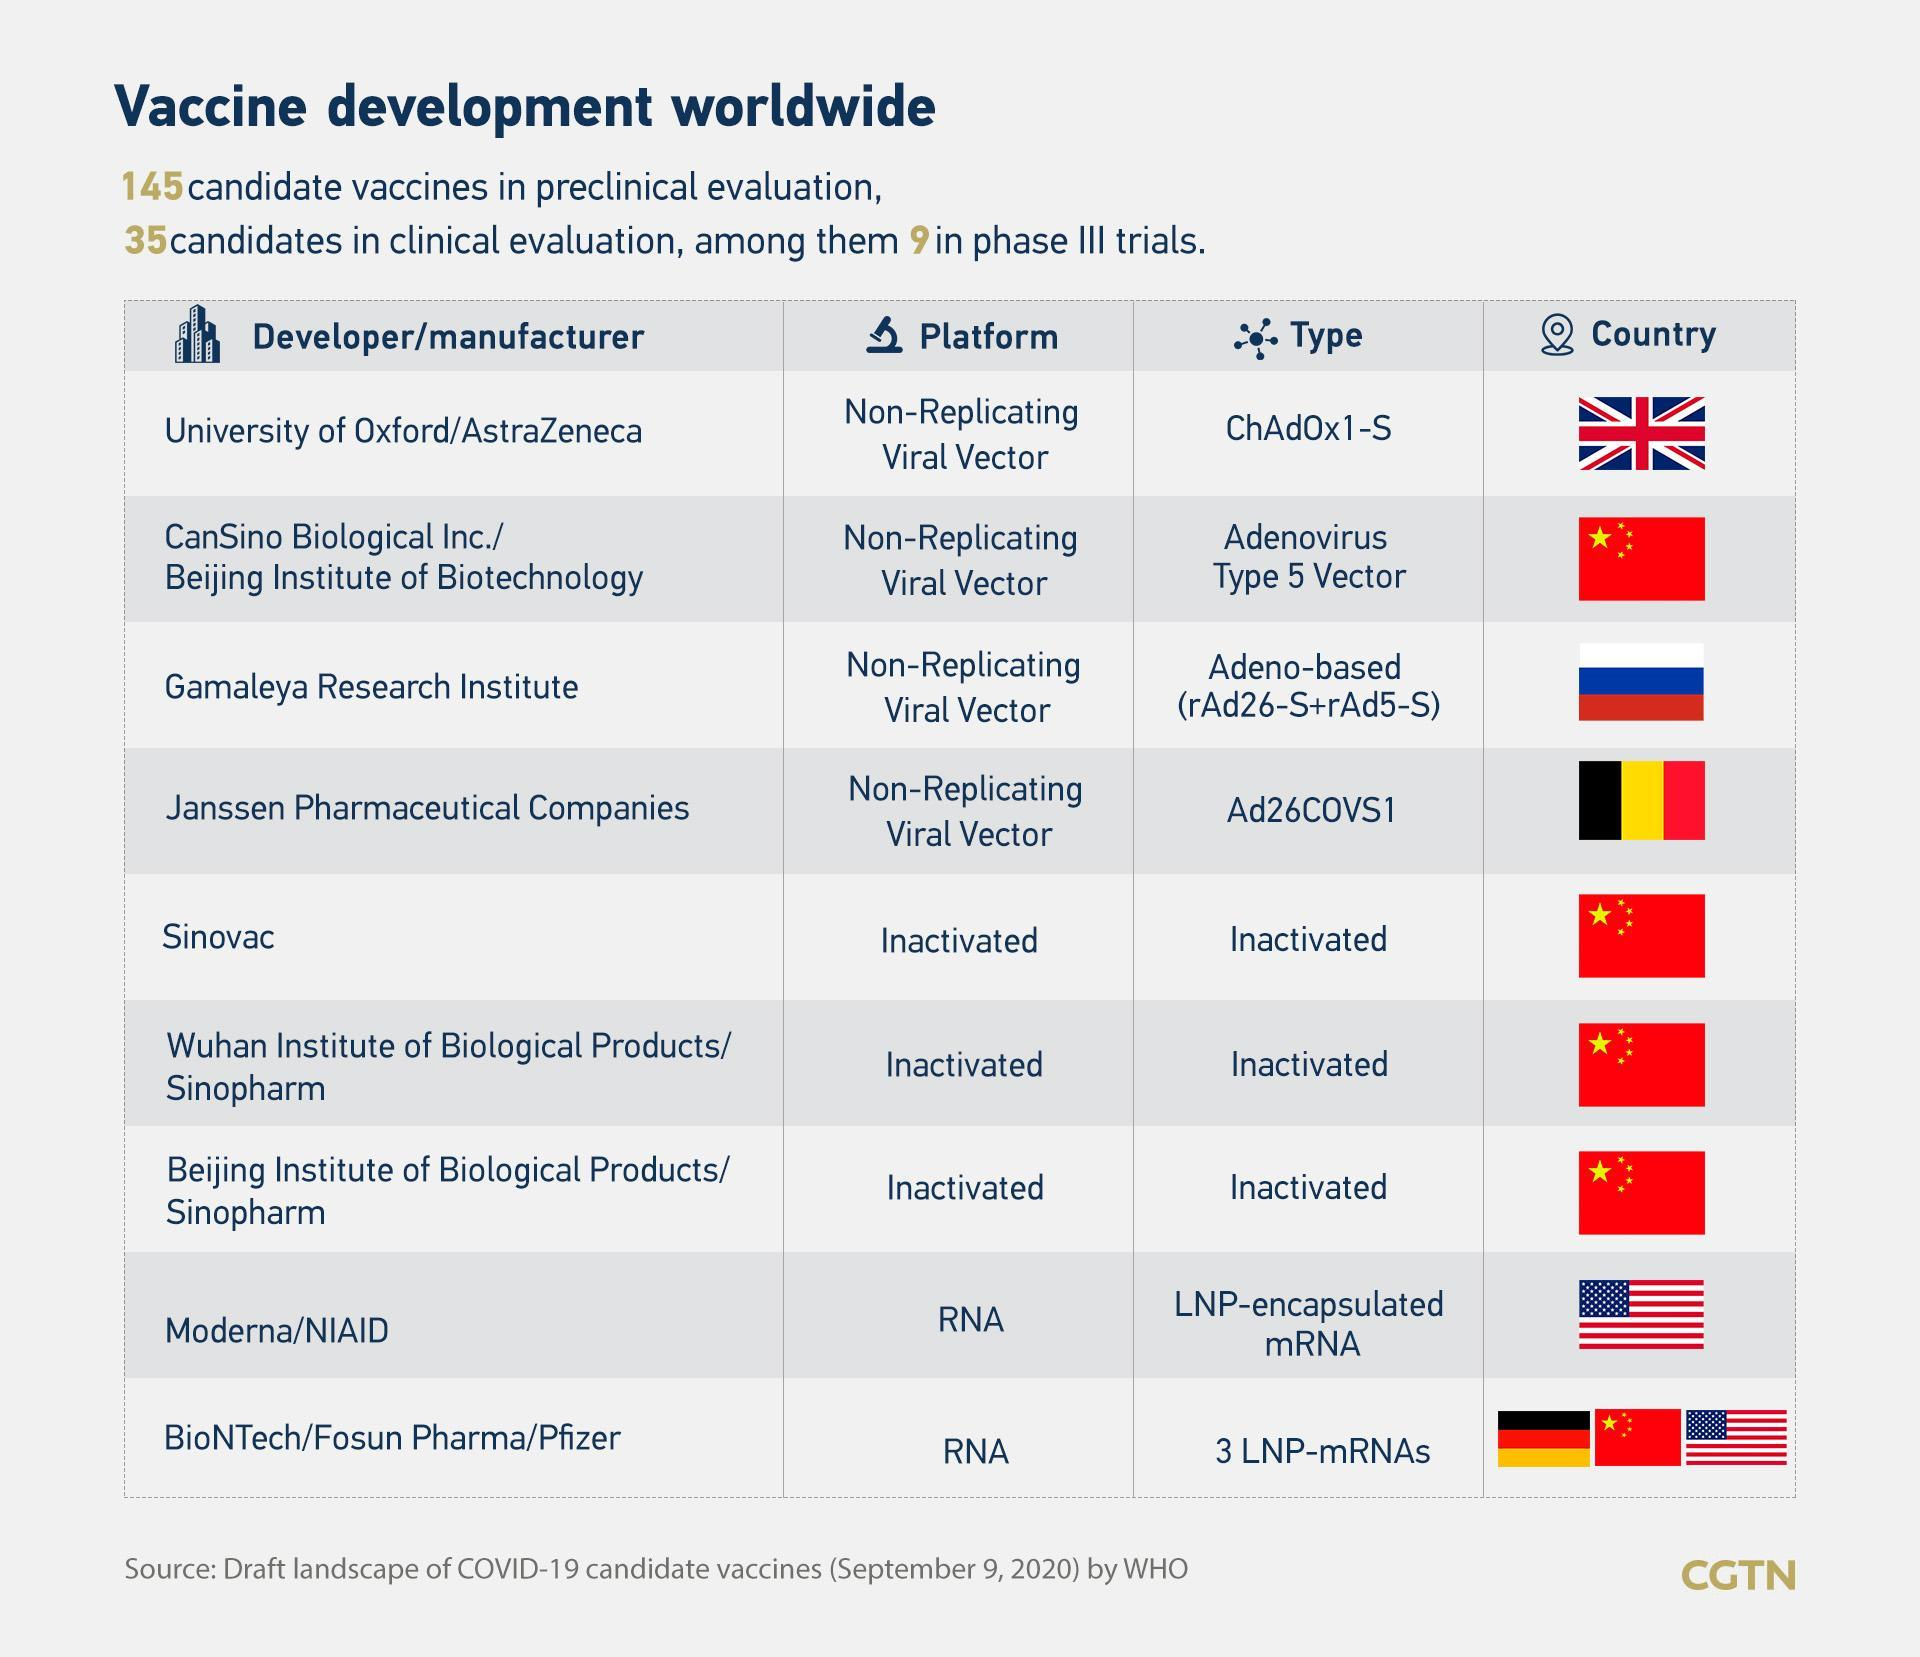How many vaccines are of type Inactivated?
Answer the question with a short phrase. 3 How many vaccines are of Non-Replicating Viral Vector platform? 4 Manufacturer from which country is developing LNP-encapsulated mRNA type vaccine - China, UK or USA? USA How many developers have been listed? 9 Which of the manufacturers is from Russia? Gamaleya Research Institute Which type of vaccine is being developed in UK? ChAdOx1-S Which is the manufacturer in Belgium? Janssen Pharmaceutical Companies Which manufacturer is developing LNP-encapsulated mRNA type vaccine? Moderna/NIAID The inactivated type vaccines are developed in which country - China, UK or USA? China How many vaccines are of RNA platform? 2 